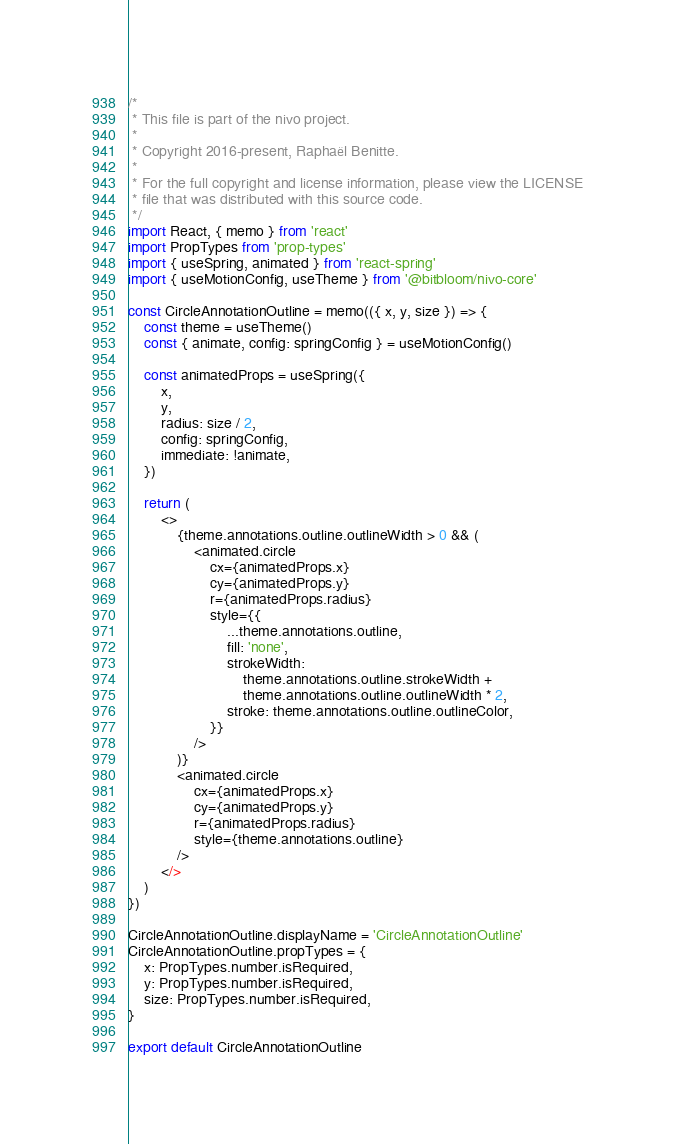<code> <loc_0><loc_0><loc_500><loc_500><_JavaScript_>/*
 * This file is part of the nivo project.
 *
 * Copyright 2016-present, Raphaël Benitte.
 *
 * For the full copyright and license information, please view the LICENSE
 * file that was distributed with this source code.
 */
import React, { memo } from 'react'
import PropTypes from 'prop-types'
import { useSpring, animated } from 'react-spring'
import { useMotionConfig, useTheme } from '@bitbloom/nivo-core'

const CircleAnnotationOutline = memo(({ x, y, size }) => {
    const theme = useTheme()
    const { animate, config: springConfig } = useMotionConfig()

    const animatedProps = useSpring({
        x,
        y,
        radius: size / 2,
        config: springConfig,
        immediate: !animate,
    })

    return (
        <>
            {theme.annotations.outline.outlineWidth > 0 && (
                <animated.circle
                    cx={animatedProps.x}
                    cy={animatedProps.y}
                    r={animatedProps.radius}
                    style={{
                        ...theme.annotations.outline,
                        fill: 'none',
                        strokeWidth:
                            theme.annotations.outline.strokeWidth +
                            theme.annotations.outline.outlineWidth * 2,
                        stroke: theme.annotations.outline.outlineColor,
                    }}
                />
            )}
            <animated.circle
                cx={animatedProps.x}
                cy={animatedProps.y}
                r={animatedProps.radius}
                style={theme.annotations.outline}
            />
        </>
    )
})

CircleAnnotationOutline.displayName = 'CircleAnnotationOutline'
CircleAnnotationOutline.propTypes = {
    x: PropTypes.number.isRequired,
    y: PropTypes.number.isRequired,
    size: PropTypes.number.isRequired,
}

export default CircleAnnotationOutline
</code> 